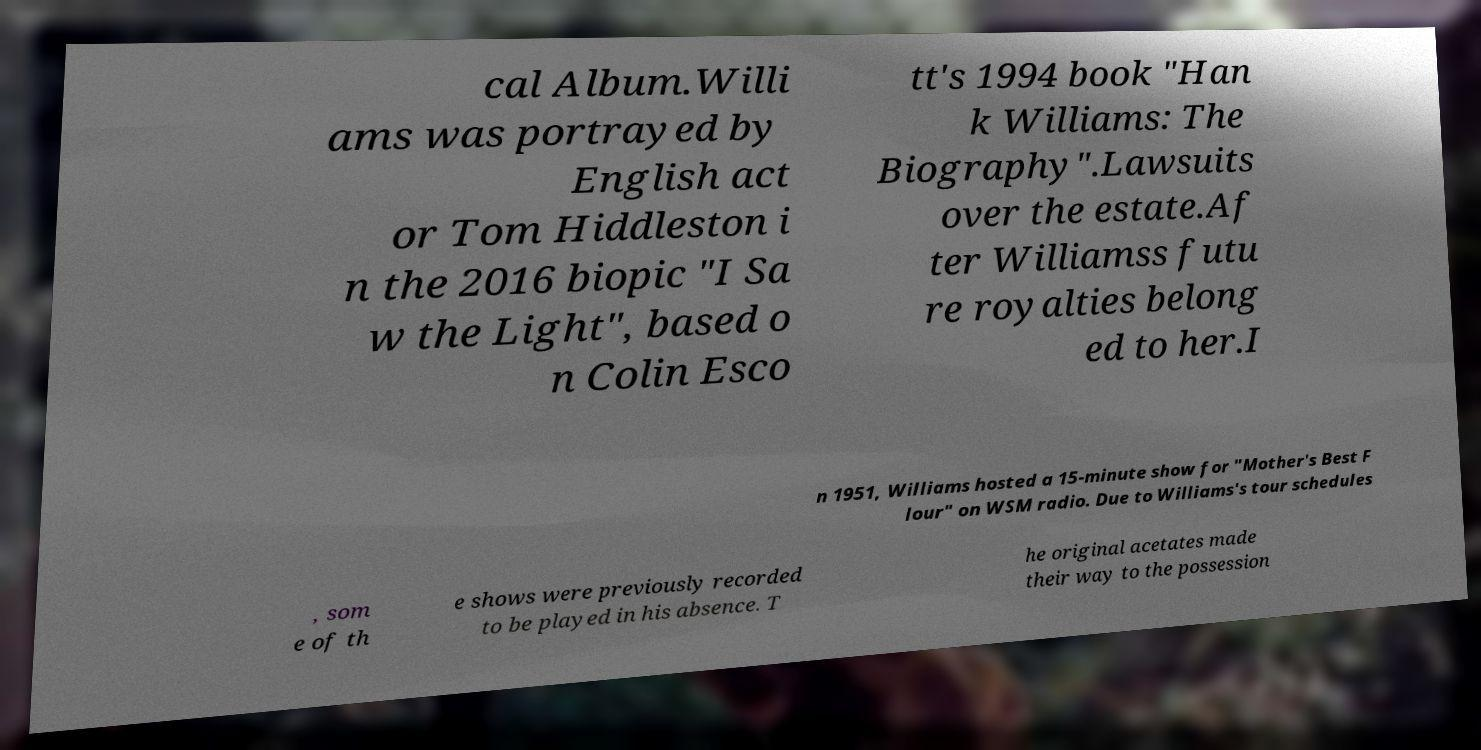Please read and relay the text visible in this image. What does it say? cal Album.Willi ams was portrayed by English act or Tom Hiddleston i n the 2016 biopic "I Sa w the Light", based o n Colin Esco tt's 1994 book "Han k Williams: The Biography".Lawsuits over the estate.Af ter Williamss futu re royalties belong ed to her.I n 1951, Williams hosted a 15-minute show for "Mother's Best F lour" on WSM radio. Due to Williams's tour schedules , som e of th e shows were previously recorded to be played in his absence. T he original acetates made their way to the possession 